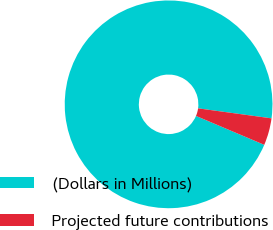<chart> <loc_0><loc_0><loc_500><loc_500><pie_chart><fcel>(Dollars in Millions)<fcel>Projected future contributions<nl><fcel>95.78%<fcel>4.22%<nl></chart> 